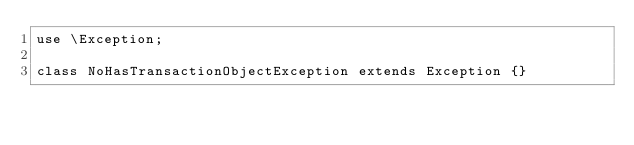Convert code to text. <code><loc_0><loc_0><loc_500><loc_500><_PHP_>use \Exception;

class NoHasTransactionObjectException extends Exception {}</code> 